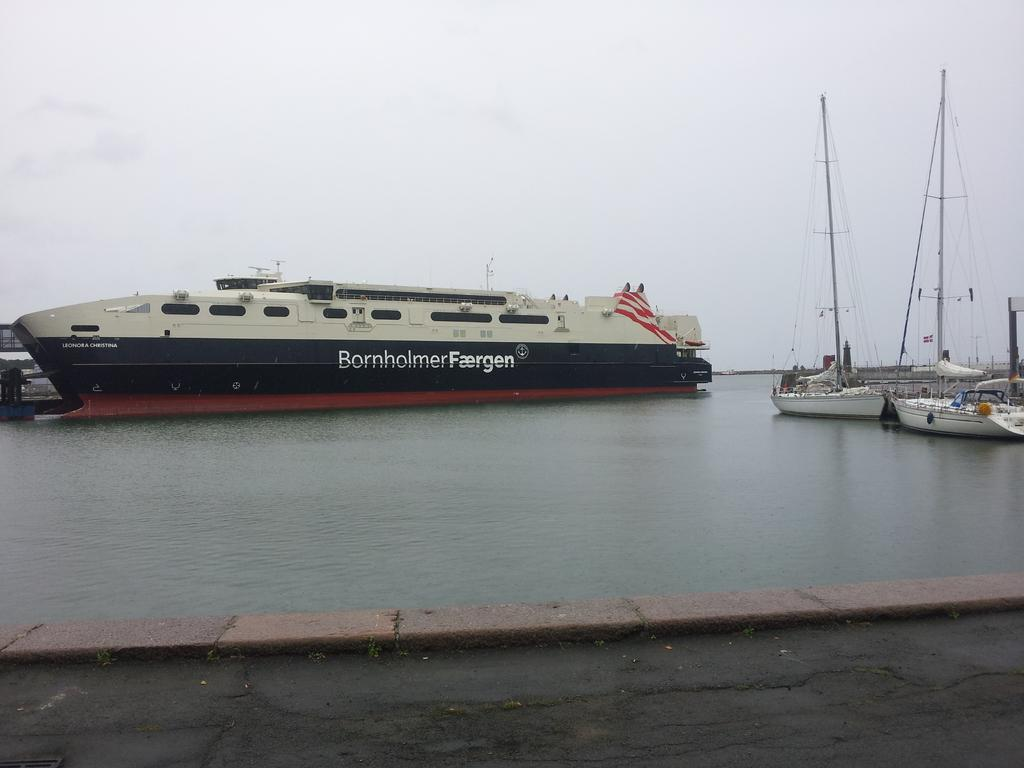Provide a one-sentence caption for the provided image. A big boat of the BornholmerFaergen company on the docks. 